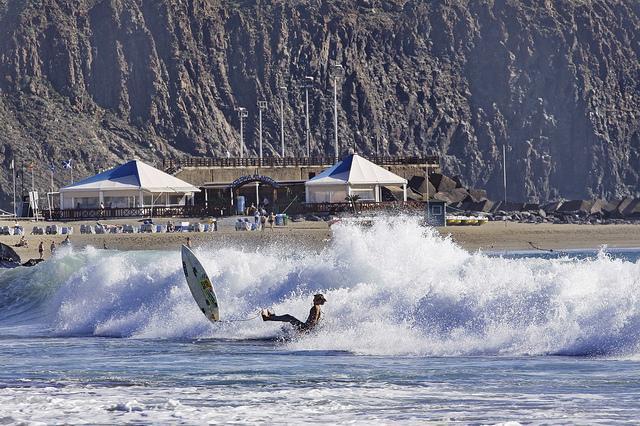Why is he not on the surfboard?
From the following set of four choices, select the accurate answer to respond to the question.
Options: Fell off, jumped off, fell asleep, too cold. Fell off. 